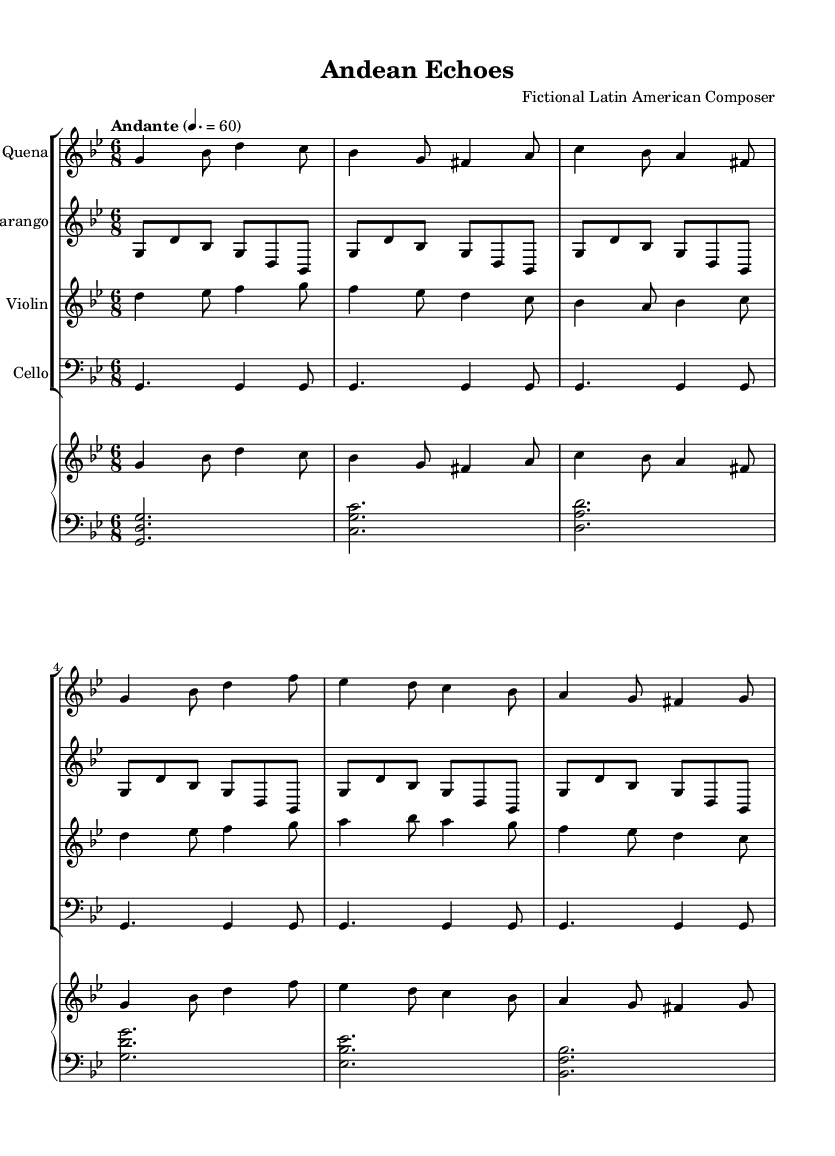What is the key signature of this music? The key signature is G minor, which has two flats (B flat and E flat). This can be determined from the beginning of the staff where these flats are indicated.
Answer: G minor What is the time signature? The time signature is 6/8, indicated at the beginning of the score just after the key signature. This means there are six eighth notes per measure.
Answer: 6/8 What is the tempo marking? The tempo marking is Andante, which suggests a moderate pace of 60 beats per minute as notated in the tempo indication.
Answer: Andante How many measures are in the first quena part? There are six measures in the quena part, as can be counted from the notes and rests contained in the section dedicated to the quena instrument.
Answer: 6 Which instruments are featured in the score? The instruments featured in the score are Quena, Charango, Violin, Cello, and Piano (divided into left and right hands). This is indicated by the names written above each staff.
Answer: Quena, Charango, Violin, Cello, Piano What melodic role does the violin play in this piece? The violin plays a melodic role with distinct and lyrical phrases, as seen in the notes progressing through measures, each containing different pitches and rhythms. This exhibits a soloistic character typical of violin parts in classical compositions.
Answer: Melodic How does the charango contribute to the texture of the piece? The charango contributes rhythmic texture by repeating short, lively figures that provide a rhythmic foundation, creating a lively ambience typical in Latin American music. This effect can be concluded from its repetitive pattern noticed throughout the charango staff notation.
Answer: Rhythmic foundation 